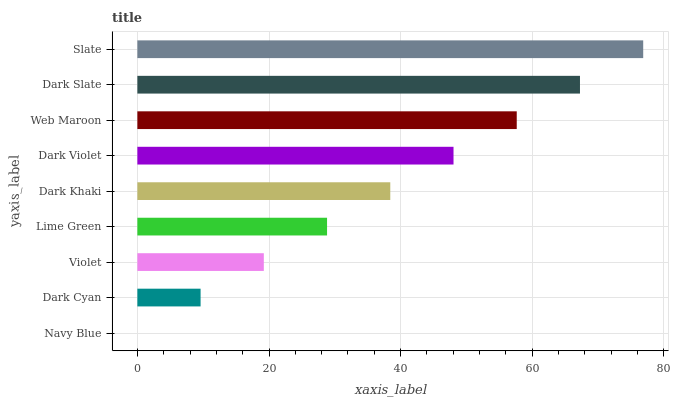Is Navy Blue the minimum?
Answer yes or no. Yes. Is Slate the maximum?
Answer yes or no. Yes. Is Dark Cyan the minimum?
Answer yes or no. No. Is Dark Cyan the maximum?
Answer yes or no. No. Is Dark Cyan greater than Navy Blue?
Answer yes or no. Yes. Is Navy Blue less than Dark Cyan?
Answer yes or no. Yes. Is Navy Blue greater than Dark Cyan?
Answer yes or no. No. Is Dark Cyan less than Navy Blue?
Answer yes or no. No. Is Dark Khaki the high median?
Answer yes or no. Yes. Is Dark Khaki the low median?
Answer yes or no. Yes. Is Dark Cyan the high median?
Answer yes or no. No. Is Dark Cyan the low median?
Answer yes or no. No. 